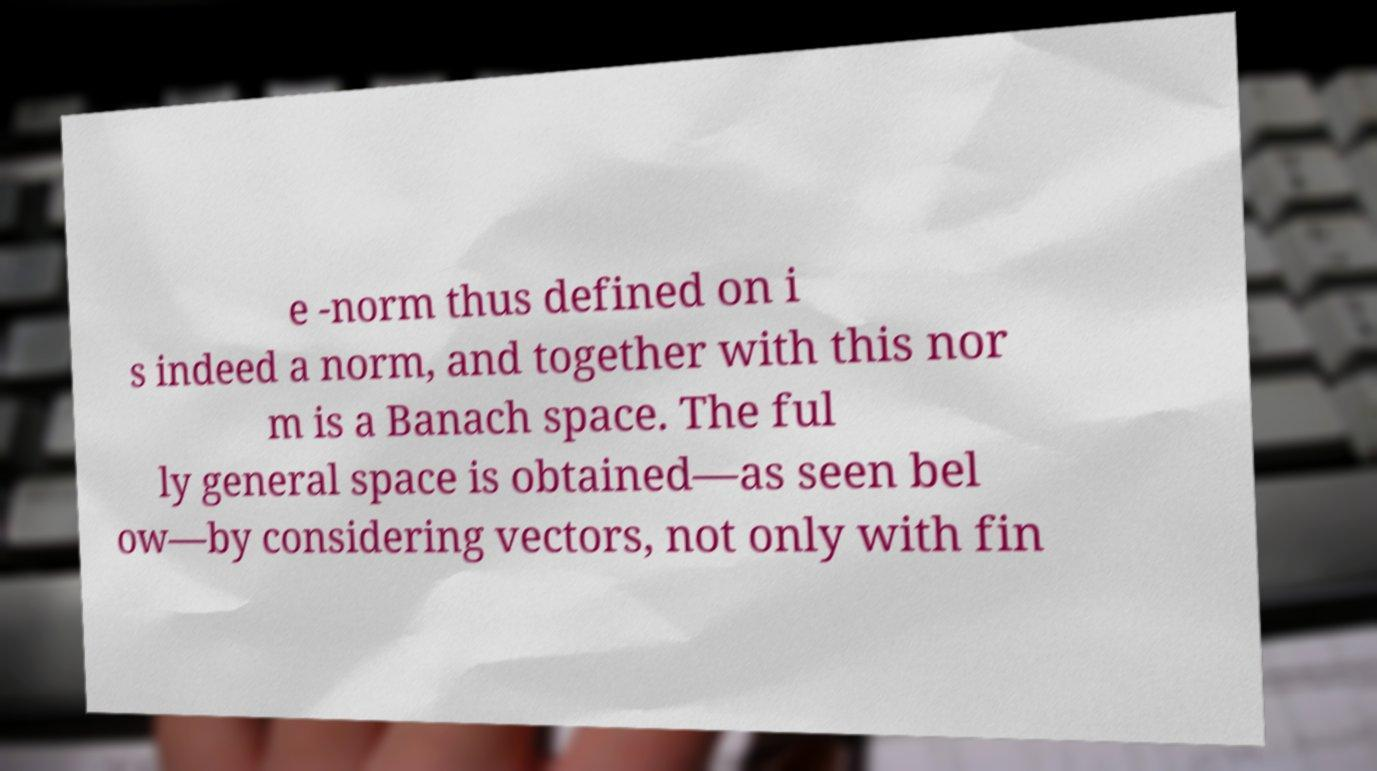What messages or text are displayed in this image? I need them in a readable, typed format. e -norm thus defined on i s indeed a norm, and together with this nor m is a Banach space. The ful ly general space is obtained—as seen bel ow—by considering vectors, not only with fin 